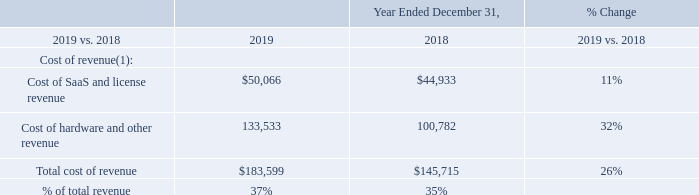Comparison of Years Ended December 31, 2019 to December 31, 2018
The following tables in this section set forth our selected consolidated statements of operations (in thousands), data for the percentage change and data as a percentage of revenue for the years ended December 31, 2019 and 2018. Certain previously reported amounts in the consolidated statements of operations for the year ended December 31, 2018 have been reclassified to conform to our current presentation to reflect interest income as a separate line item, which was previously included in other income, net.
Cost of Revenue
(1) Excludes amortization and depreciation shown in operating expenses.
The $37.9 million increase in cost of revenue in 2019 as compared to 2018 was the result of a $32.8 million, or 32%, increase in cost of hardware and other revenue and a $5.1 million, or 11%, increase in cost of SaaS and license revenue. Our cost of software license revenue included within cost of SaaS and license revenue decreased $0.4 million to $1.3 million during 2019 as compared to $1.7 million during 2018. The increase in cost of Alarm.com segment hardware and other revenue related primarily to an increase in the number of hardware units shipped in 2019 as compared to 2018. The increase in cost of  corresponding increase in amounts paid to wireless network providers.
Cost of hardware and other revenue as a percentage of hardware and other revenue was 81% and 78% for the years ended December 31, 2019 and 2018, respectively. Cost of SaaS and license revenue as a percentage of SaaS and license revenue was 15% for each of the years ended December 31, 2019 and 2018. Cost of software license revenue as a percentage of software license revenue was 3% and 4% for the years ended December 31, 2019 and 2018, respectively. The increase in cost of hardware and other revenue as a percentage of hardware and other revenue in 2019 as compared to 2018 is a reflection of the mix of product sales during the periods.
What was the Cost of SaaS and license revenue in 2019?
Answer scale should be: thousand. $50,066. What was the Cost of hardware and other revenue in 2018?
Answer scale should be: thousand. 100,782. What was the total cost of revenue in 2018?
Answer scale should be: thousand. $145,715. How many years did total cost of revenue exceed $150,000 thousand? 2019
Answer: 1. How many costs of revenue exceeded $100,000 thousand in 2019? Cost of hardware and other revenue
Answer: 1. What was the change in total cost of revenue as a percentage of total revenue between 2018 and 2019?
Answer scale should be: percent. 37-35
Answer: 2. 